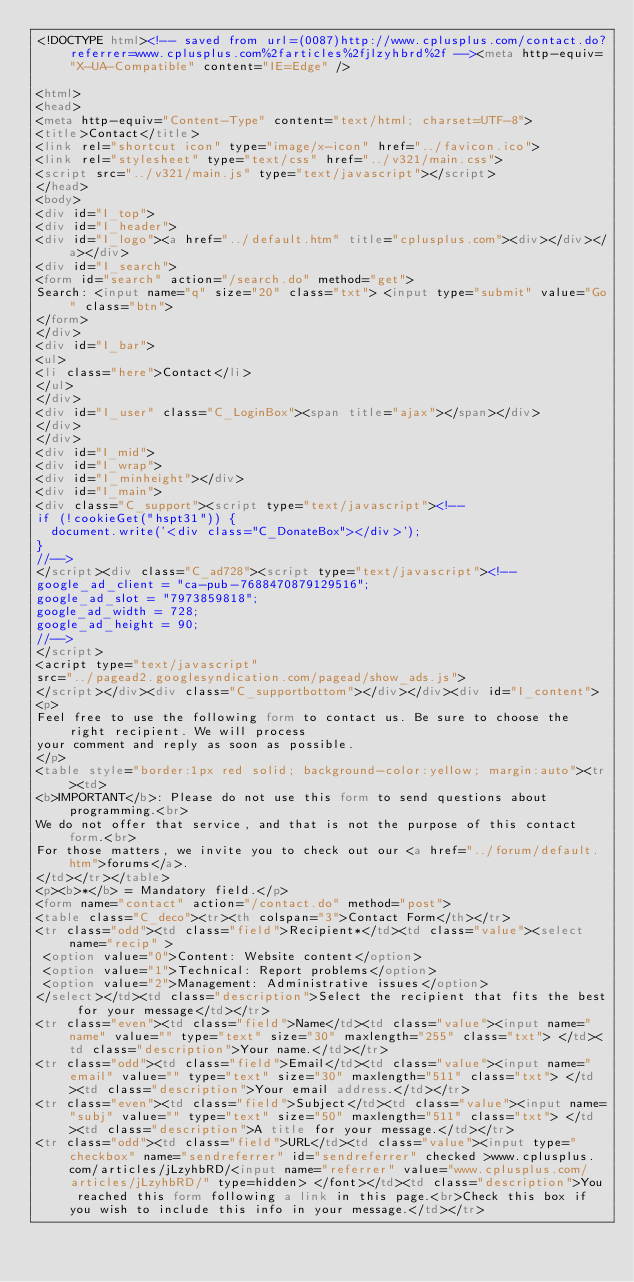Convert code to text. <code><loc_0><loc_0><loc_500><loc_500><_HTML_><!DOCTYPE html><!-- saved from url=(0087)http://www.cplusplus.com/contact.do?referrer=www.cplusplus.com%2farticles%2fjlzyhbrd%2f --><meta http-equiv="X-UA-Compatible" content="IE=Edge" />

<html>
<head>
<meta http-equiv="Content-Type" content="text/html; charset=UTF-8">
<title>Contact</title>
<link rel="shortcut icon" type="image/x-icon" href="../favicon.ico">
<link rel="stylesheet" type="text/css" href="../v321/main.css">
<script src="../v321/main.js" type="text/javascript"></script>
</head>
<body>
<div id="I_top">
<div id="I_header">
<div id="I_logo"><a href="../default.htm" title="cplusplus.com"><div></div></a></div>
<div id="I_search">
<form id="search" action="/search.do" method="get">
Search: <input name="q" size="20" class="txt"> <input type="submit" value="Go" class="btn">
</form>
</div>
<div id="I_bar">
<ul>
<li class="here">Contact</li>
</ul>
</div>
<div id="I_user" class="C_LoginBox"><span title="ajax"></span></div>
</div>
</div>
<div id="I_mid">
<div id="I_wrap">
<div id="I_minheight"></div>
<div id="I_main">
<div class="C_support"><script type="text/javascript"><!--
if (!cookieGet("hspt31")) {
  document.write('<div class="C_DonateBox"></div>');
}
//-->
</script><div class="C_ad728"><script type="text/javascript"><!--
google_ad_client = "ca-pub-7688470879129516";
google_ad_slot = "7973859818";
google_ad_width = 728;
google_ad_height = 90;
//-->
</script>
<acript type="text/javascript"
src="../pagead2.googlesyndication.com/pagead/show_ads.js">
</script></div><div class="C_supportbottom"></div></div><div id="I_content">
<p>
Feel free to use the following form to contact us. Be sure to choose the right recipient. We will process
your comment and reply as soon as possible.
</p>
<table style="border:1px red solid; background-color:yellow; margin:auto"><tr><td>
<b>IMPORTANT</b>: Please do not use this form to send questions about programming.<br>
We do not offer that service, and that is not the purpose of this contact form.<br>
For those matters, we invite you to check out our <a href="../forum/default.htm">forums</a>.
</td></tr></table>
<p><b>*</b> = Mandatory field.</p>
<form name="contact" action="/contact.do" method="post">
<table class="C_deco"><tr><th colspan="3">Contact Form</th></tr>
<tr class="odd"><td class="field">Recipient*</td><td class="value"><select name="recip" >
 <option value="0">Content: Website content</option>
 <option value="1">Technical: Report problems</option>
 <option value="2">Management: Administrative issues</option>
</select></td><td class="description">Select the recipient that fits the best for your message</td></tr>
<tr class="even"><td class="field">Name</td><td class="value"><input name="name" value="" type="text" size="30" maxlength="255" class="txt"> </td><td class="description">Your name.</td></tr>
<tr class="odd"><td class="field">Email</td><td class="value"><input name="email" value="" type="text" size="30" maxlength="511" class="txt"> </td><td class="description">Your email address.</td></tr>
<tr class="even"><td class="field">Subject</td><td class="value"><input name="subj" value="" type="text" size="50" maxlength="511" class="txt"> </td><td class="description">A title for your message.</td></tr>
<tr class="odd"><td class="field">URL</td><td class="value"><input type="checkbox" name="sendreferrer" id="sendreferrer" checked >www.cplusplus.com/articles/jLzyhbRD/<input name="referrer" value="www.cplusplus.com/articles/jLzyhbRD/" type=hidden> </font></td><td class="description">You reached this form following a link in this page.<br>Check this box if you wish to include this info in your message.</td></tr></code> 